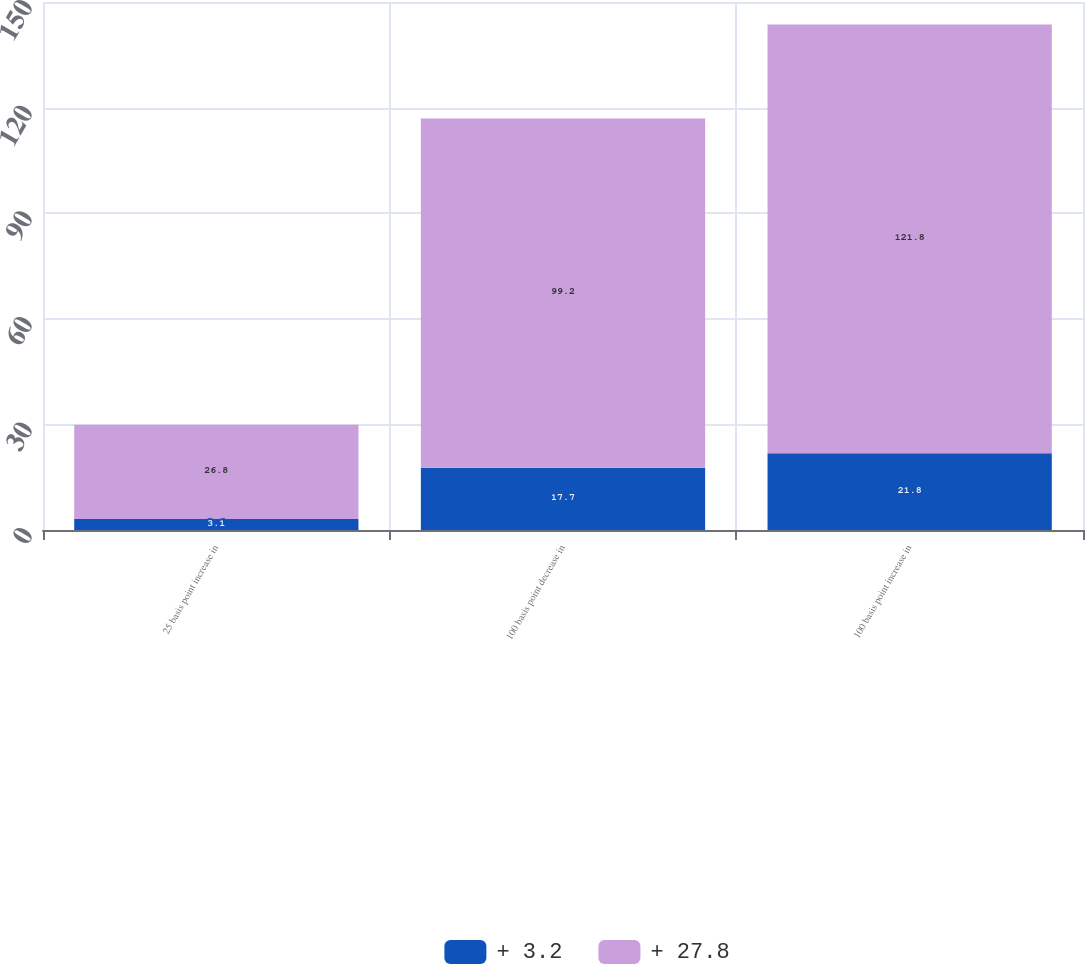Convert chart. <chart><loc_0><loc_0><loc_500><loc_500><stacked_bar_chart><ecel><fcel>25 basis point increase in<fcel>100 basis point decrease in<fcel>100 basis point increase in<nl><fcel>+ 3.2<fcel>3.1<fcel>17.7<fcel>21.8<nl><fcel>+ 27.8<fcel>26.8<fcel>99.2<fcel>121.8<nl></chart> 